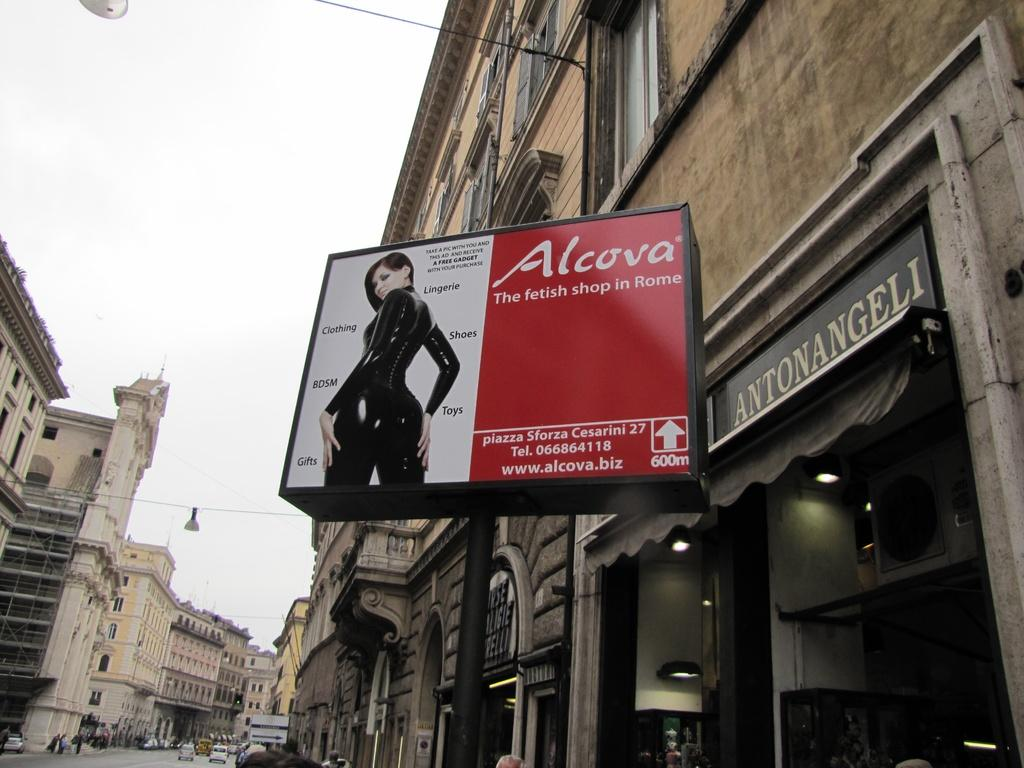<image>
Offer a succinct explanation of the picture presented. the name alcova is on the red and white sign 